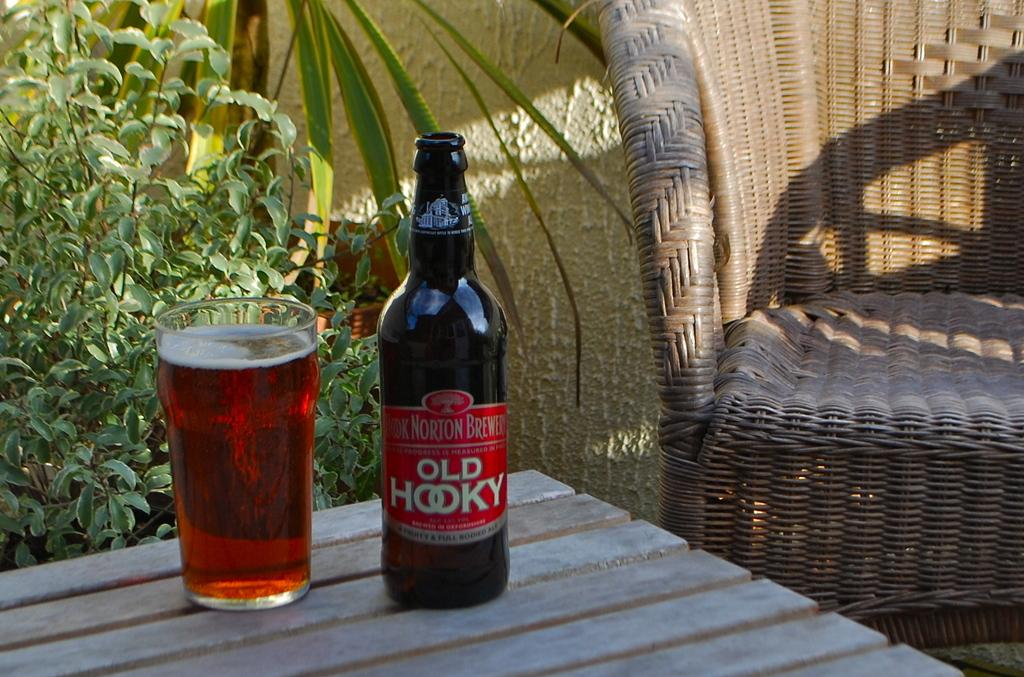<image>
Render a clear and concise summary of the photo. A bottle of Old Hooky sits on the table next to a filled glass of the drink. 